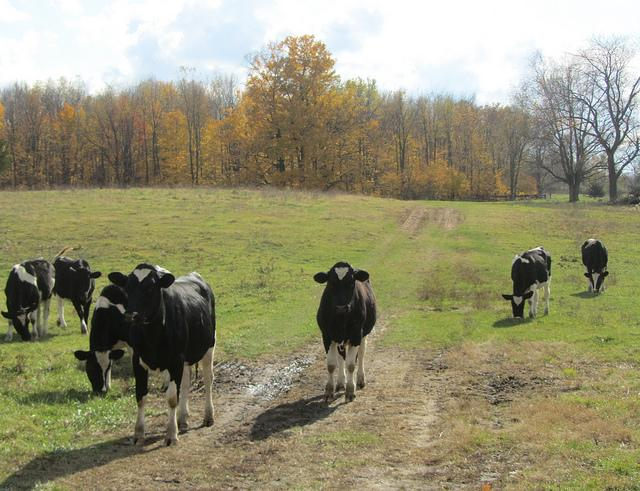What likely made the tracks on the ground? Please explain your reasoning. truck. There are two rows of tires and cows need extra feed sometimes. 